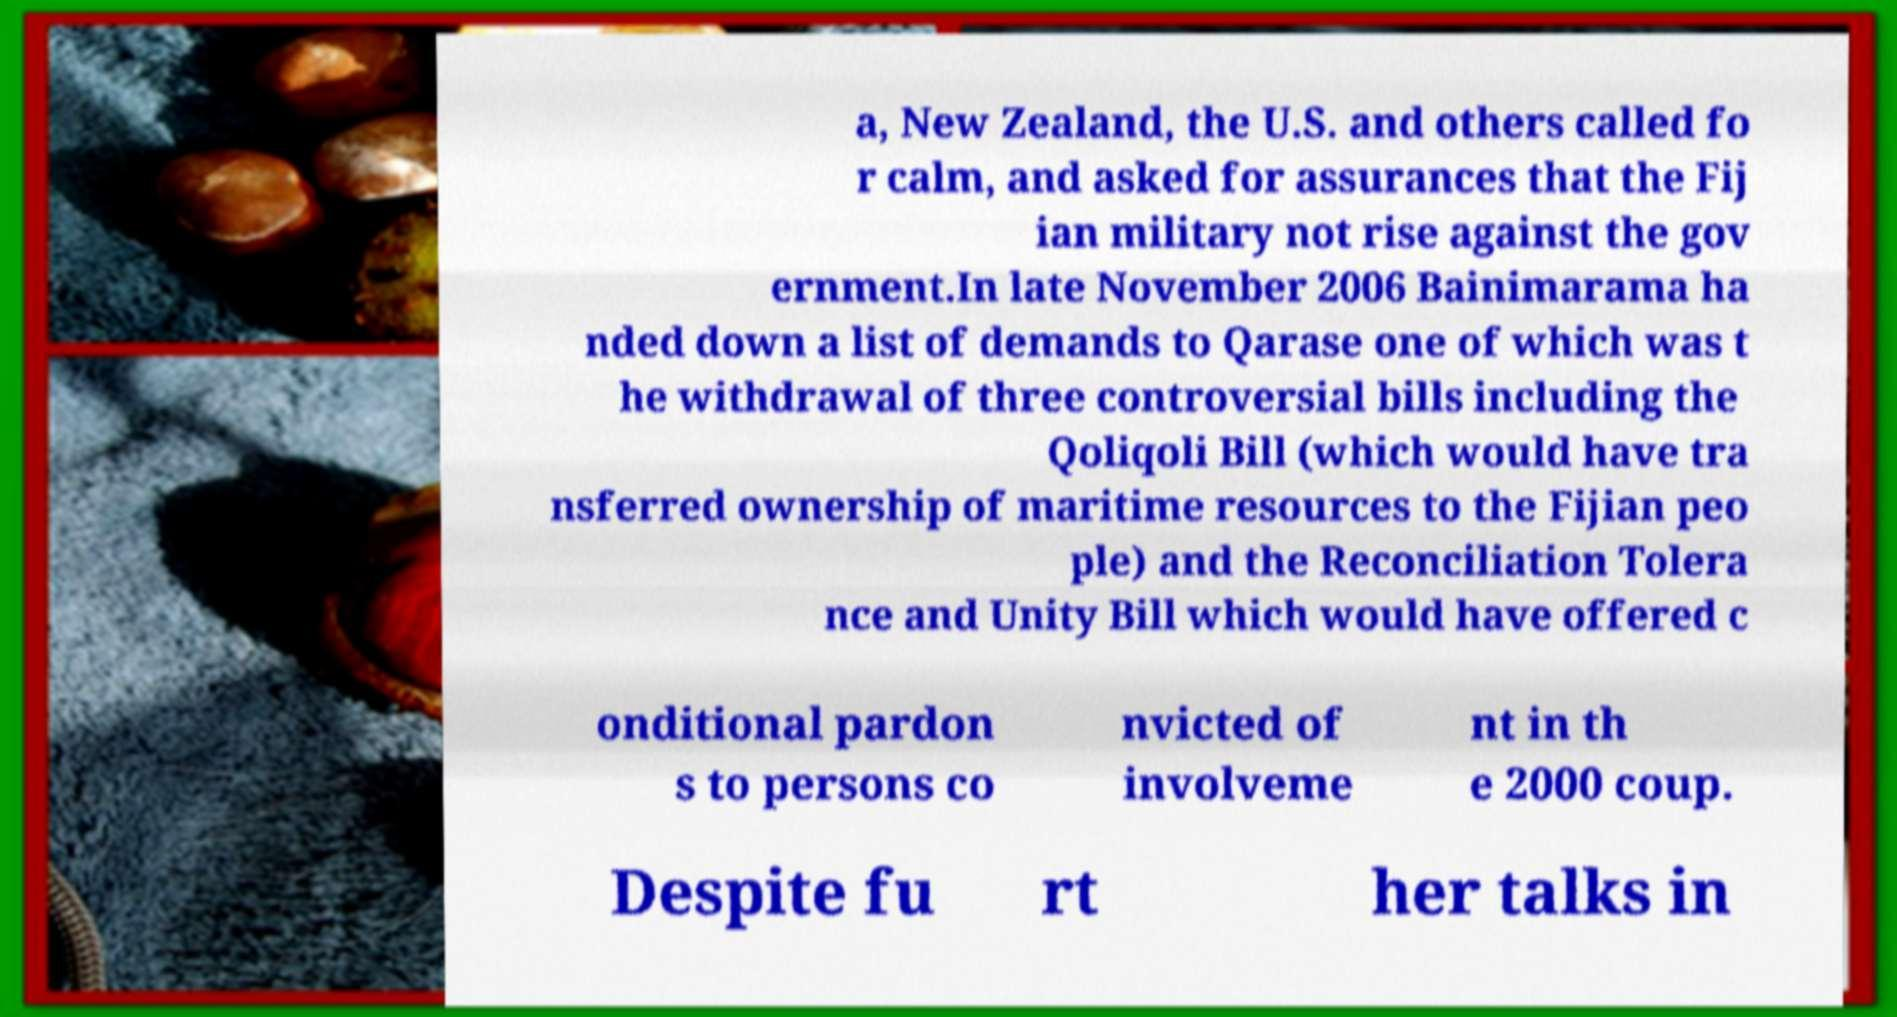There's text embedded in this image that I need extracted. Can you transcribe it verbatim? a, New Zealand, the U.S. and others called fo r calm, and asked for assurances that the Fij ian military not rise against the gov ernment.In late November 2006 Bainimarama ha nded down a list of demands to Qarase one of which was t he withdrawal of three controversial bills including the Qoliqoli Bill (which would have tra nsferred ownership of maritime resources to the Fijian peo ple) and the Reconciliation Tolera nce and Unity Bill which would have offered c onditional pardon s to persons co nvicted of involveme nt in th e 2000 coup. Despite fu rt her talks in 